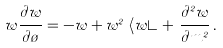Convert formula to latex. <formula><loc_0><loc_0><loc_500><loc_500>w \frac { \partial w } { \partial \tau } = - w + w ^ { 2 } \, \left \langle w \right \rangle + \, \frac { \partial ^ { 2 } w } { \partial m ^ { 2 } } \, .</formula> 